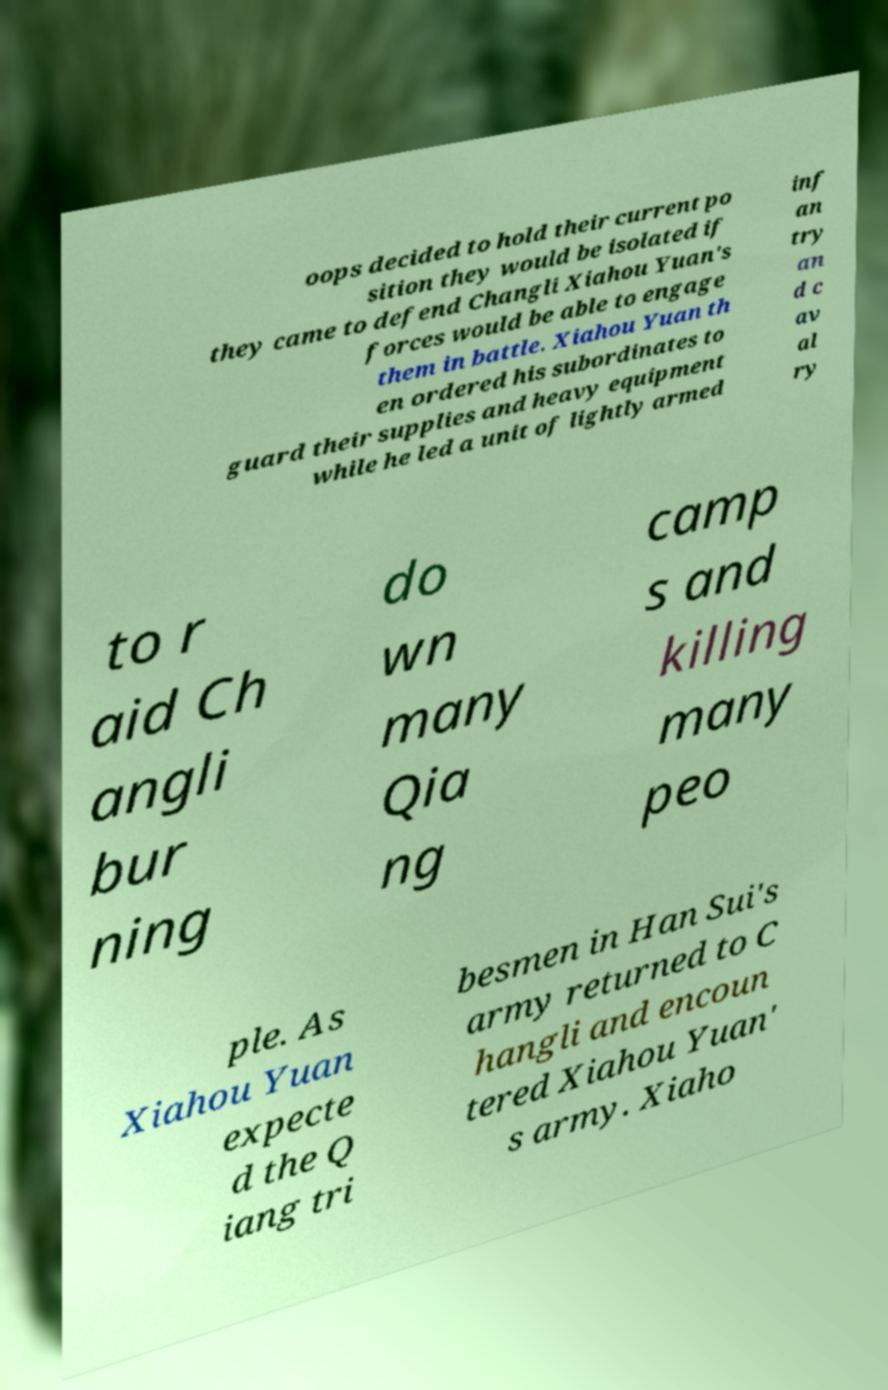Please read and relay the text visible in this image. What does it say? oops decided to hold their current po sition they would be isolated if they came to defend Changli Xiahou Yuan's forces would be able to engage them in battle. Xiahou Yuan th en ordered his subordinates to guard their supplies and heavy equipment while he led a unit of lightly armed inf an try an d c av al ry to r aid Ch angli bur ning do wn many Qia ng camp s and killing many peo ple. As Xiahou Yuan expecte d the Q iang tri besmen in Han Sui's army returned to C hangli and encoun tered Xiahou Yuan' s army. Xiaho 